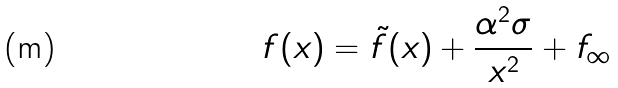Convert formula to latex. <formula><loc_0><loc_0><loc_500><loc_500>f ( x ) = \tilde { f } ( x ) + \frac { \alpha ^ { 2 } \sigma } { x ^ { 2 } } + f _ { \infty }</formula> 